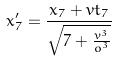<formula> <loc_0><loc_0><loc_500><loc_500>x _ { 7 } ^ { \prime } = \frac { x _ { 7 } + v t _ { 7 } } { \sqrt { 7 + \frac { v ^ { 3 } } { o ^ { 3 } } } }</formula> 